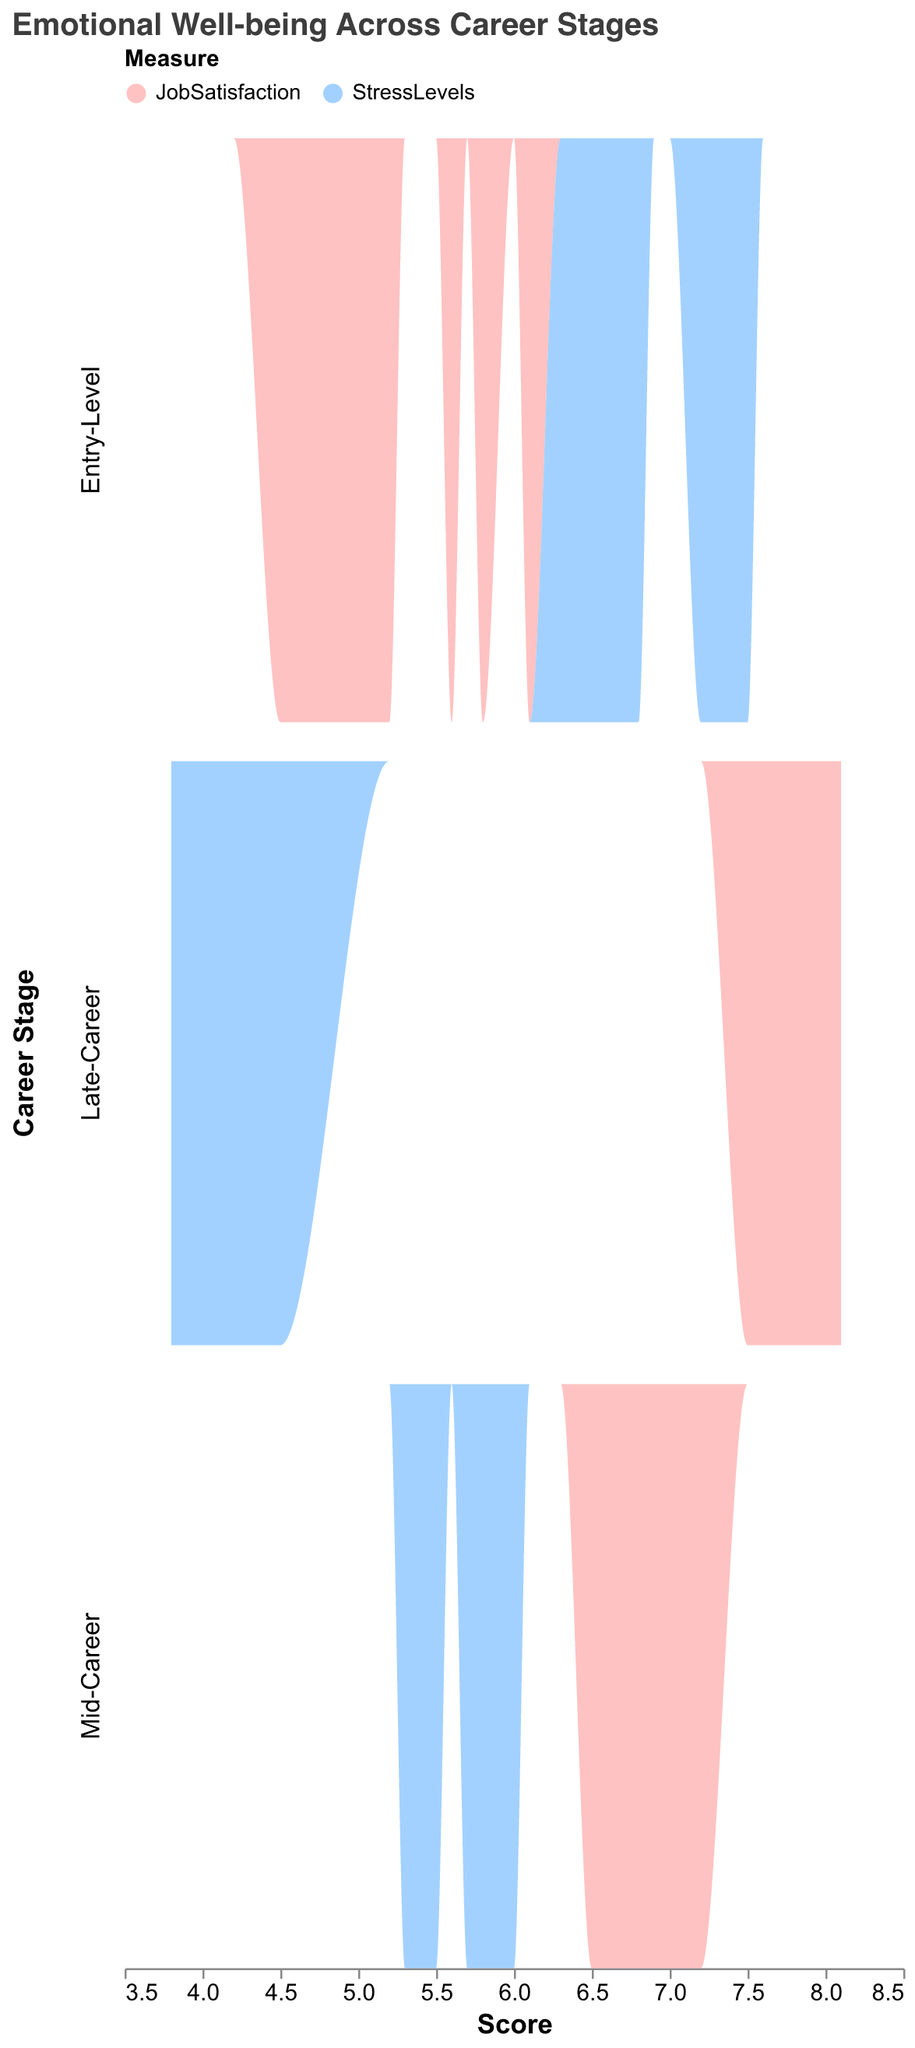What is the title of the figure? The title is displayed at the top of the figure in a larger font size. It reads "Emotional Well-being Across Career Stages".
Answer: Emotional Well-being Across Career Stages What does the x-axis represent? The x-axis represents the "Score", which likely refers to the values for Job Satisfaction and Stress Levels.
Answer: Score Which career stage has the highest average job satisfaction? By comparing the density distributions, the highest average job satisfaction appears to be in the Late-Career stage, as this distribution ascends to higher satisfaction scores more frequently.
Answer: Late-Career How do stress levels vary between Entry-Level and Late-Career stages? The density plot shows that Entry-Level stages have higher stress levels, with scores clustering around higher values. In contrast, Late-Career stages show lower stress levels with a shift toward lower scores.
Answer: Entry-Level has higher stress, Late-Career has lower stress Which variable uses the blue color in the density plot? The legend at the top of the plot shows that the blue color represents Stress Levels.
Answer: Stress Levels Compare the variability in job satisfaction between Mid-Career and Entry-Level stages. Variability can be seen by the width of the peak in the density plot. Job Satisfaction in the Mid-Career stage has a wider peak than Entry-Level, indicating greater variability.
Answer: Mid-Career has greater variability In which career stage does stress level vary the least? The density plot shows that Stress Levels in the Late-Career stage have a narrower peak compared to the other stages, indicating less variability.
Answer: Late-Career What is the relative position of the peak of stress levels for the Entry-Level and Mid-Career stages? The peak of Stress Levels in the Entry-Level stage is situated at a higher score compared to the Mid-Career stage, indicating more stress in the earlier career stages.
Answer: Entry-Level is higher How does job satisfaction trend as career stages advance? Observing the density plots, job satisfaction generally increases as career stages advance from Entry-Level to Late-Career stages. Higher peaks for satisfaction are seen in Mid-Career and Late-Career stages.
Answer: Increases 